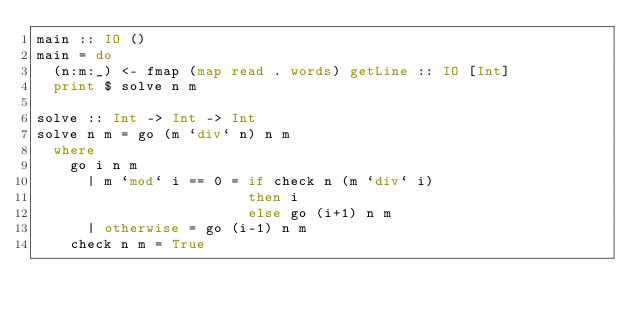Convert code to text. <code><loc_0><loc_0><loc_500><loc_500><_Haskell_>main :: IO ()
main = do
  (n:m:_) <- fmap (map read . words) getLine :: IO [Int]
  print $ solve n m

solve :: Int -> Int -> Int
solve n m = go (m `div` n) n m
  where
    go i n m
      | m `mod` i == 0 = if check n (m `div` i)
                         then i
                         else go (i+1) n m
      | otherwise = go (i-1) n m
    check n m = True
</code> 